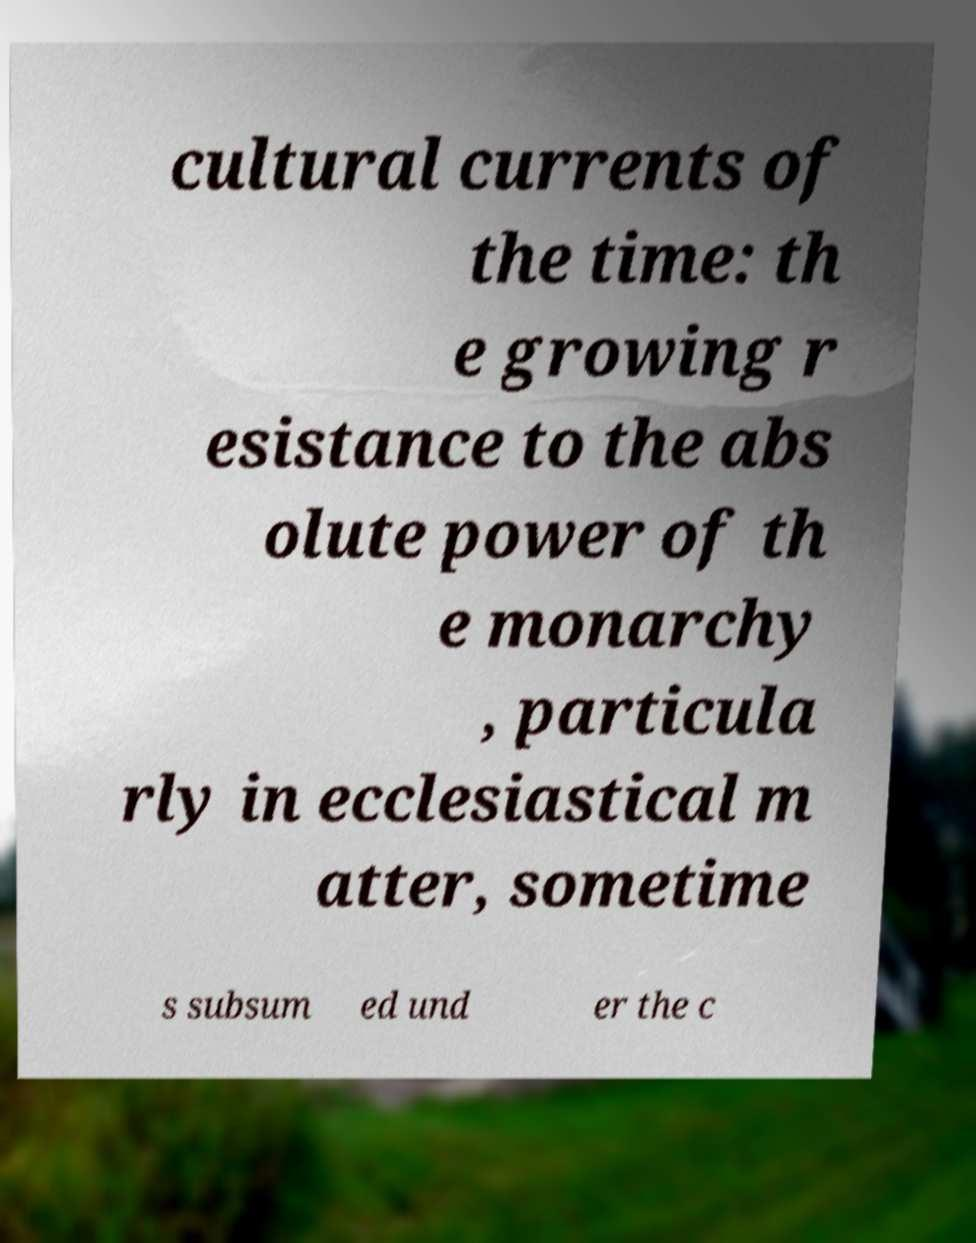Please identify and transcribe the text found in this image. cultural currents of the time: th e growing r esistance to the abs olute power of th e monarchy , particula rly in ecclesiastical m atter, sometime s subsum ed und er the c 